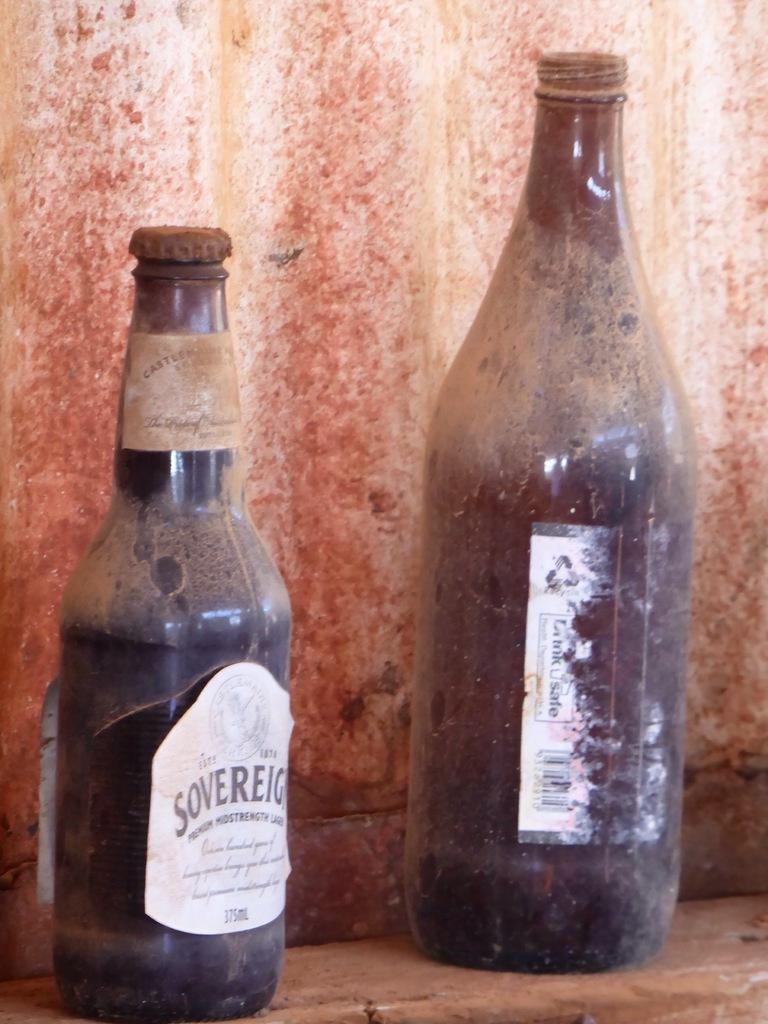What kind of wine is this?
Ensure brevity in your answer.  Unanswerable. How many ml is the bottle?
Keep it short and to the point. 375. 